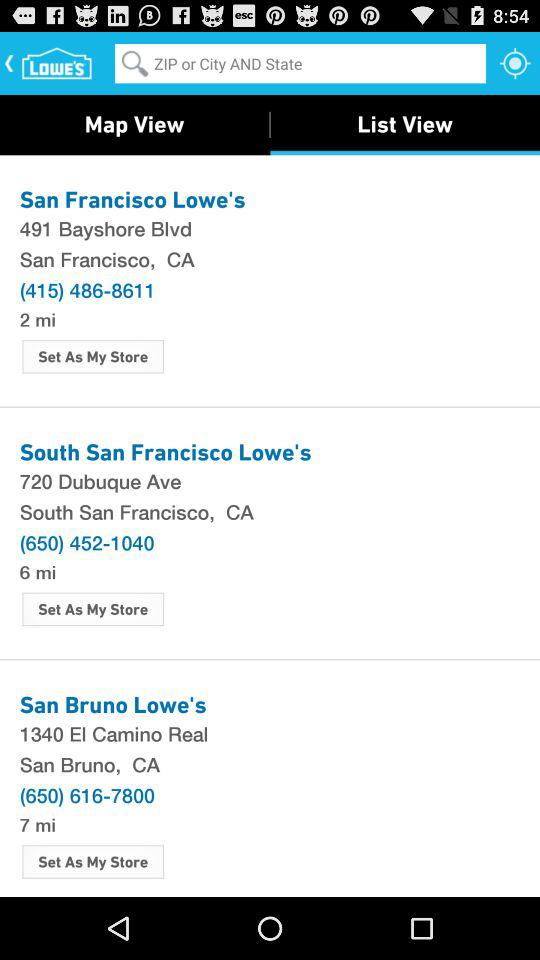What is the contact number for San Bruno Lowe's? The contact number is (650) 616-7800. 